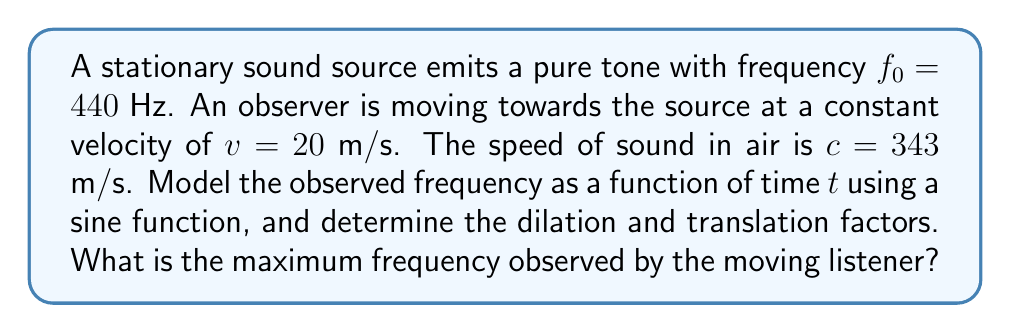Give your solution to this math problem. To model the Doppler effect for a moving observer and stationary source, we need to consider how the frequency changes over time. We'll use a sine function as our base periodic function and apply appropriate transformations.

1) The general form of a sine function with dilation and translation is:
   $f(t) = A \sin(B(t - C)) + D$

2) In this case, A is the amplitude of frequency change, B is the angular frequency, C is the phase shift, and D is the vertical shift.

3) The Doppler effect formula for a moving observer and stationary source is:
   $f = f_0 \left(\frac{c}{c-v}\right)$

4) Substituting the given values:
   $f = 440 \left(\frac{343}{343-20}\right) = 466.4$ Hz

5) This is the maximum frequency observed. The frequency will oscillate between 440 Hz and 466.4 Hz.

6) The amplitude of the oscillation is:
   $A = \frac{466.4 - 440}{2} = 13.2$ Hz

7) The average frequency is:
   $D = \frac{466.4 + 440}{2} = 453.2$ Hz

8) The period of oscillation is determined by the time it takes the observer to move one wavelength. The wavelength at 440 Hz is:
   $\lambda = \frac{c}{f_0} = \frac{343}{440} = 0.78$ m

9) The time to move one wavelength:
   $T = \frac{\lambda}{v} = \frac{0.78}{20} = 0.039$ s

10) The angular frequency is:
    $B = \frac{2\pi}{T} = \frac{2\pi}{0.039} = 161.2$ rad/s

11) There's no phase shift, so C = 0.

Therefore, the transformed function is:
$f(t) = 13.2 \sin(161.2t) + 453.2$

The dilation factor is 161.2, and the translation factor is 453.2 (vertical shift).
Answer: The transformed function modeling the observed frequency is:
$f(t) = 13.2 \sin(161.2t) + 453.2$

Dilation factor: 161.2
Translation factor (vertical shift): 453.2

The maximum frequency observed is 466.4 Hz. 